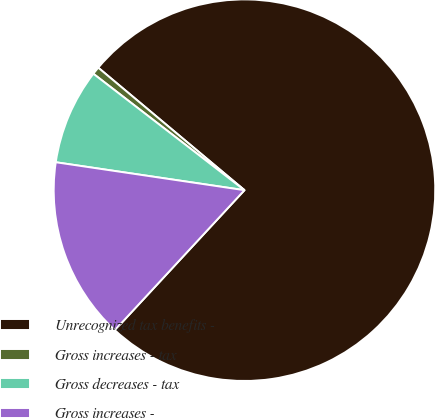Convert chart to OTSL. <chart><loc_0><loc_0><loc_500><loc_500><pie_chart><fcel>Unrecognized tax benefits -<fcel>Gross increases - tax<fcel>Gross decreases - tax<fcel>Gross increases -<nl><fcel>75.79%<fcel>0.65%<fcel>8.11%<fcel>15.45%<nl></chart> 